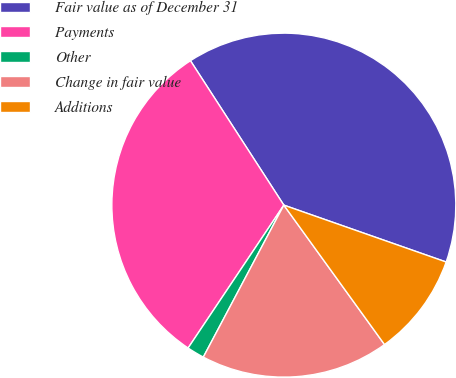Convert chart to OTSL. <chart><loc_0><loc_0><loc_500><loc_500><pie_chart><fcel>Fair value as of December 31<fcel>Payments<fcel>Other<fcel>Change in fair value<fcel>Additions<nl><fcel>39.5%<fcel>31.47%<fcel>1.64%<fcel>17.71%<fcel>9.68%<nl></chart> 